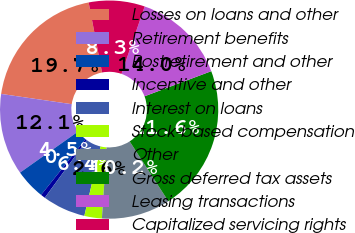Convert chart to OTSL. <chart><loc_0><loc_0><loc_500><loc_500><pie_chart><fcel>Losses on loans and other<fcel>Retirement benefits<fcel>Postretirement and other<fcel>Incentive and other<fcel>Interest on loans<fcel>Stock-based compensation<fcel>Other<fcel>Gross deferred tax assets<fcel>Leasing transactions<fcel>Capitalized servicing rights<nl><fcel>19.7%<fcel>12.09%<fcel>4.49%<fcel>0.68%<fcel>6.39%<fcel>2.59%<fcel>10.19%<fcel>21.6%<fcel>13.99%<fcel>8.29%<nl></chart> 